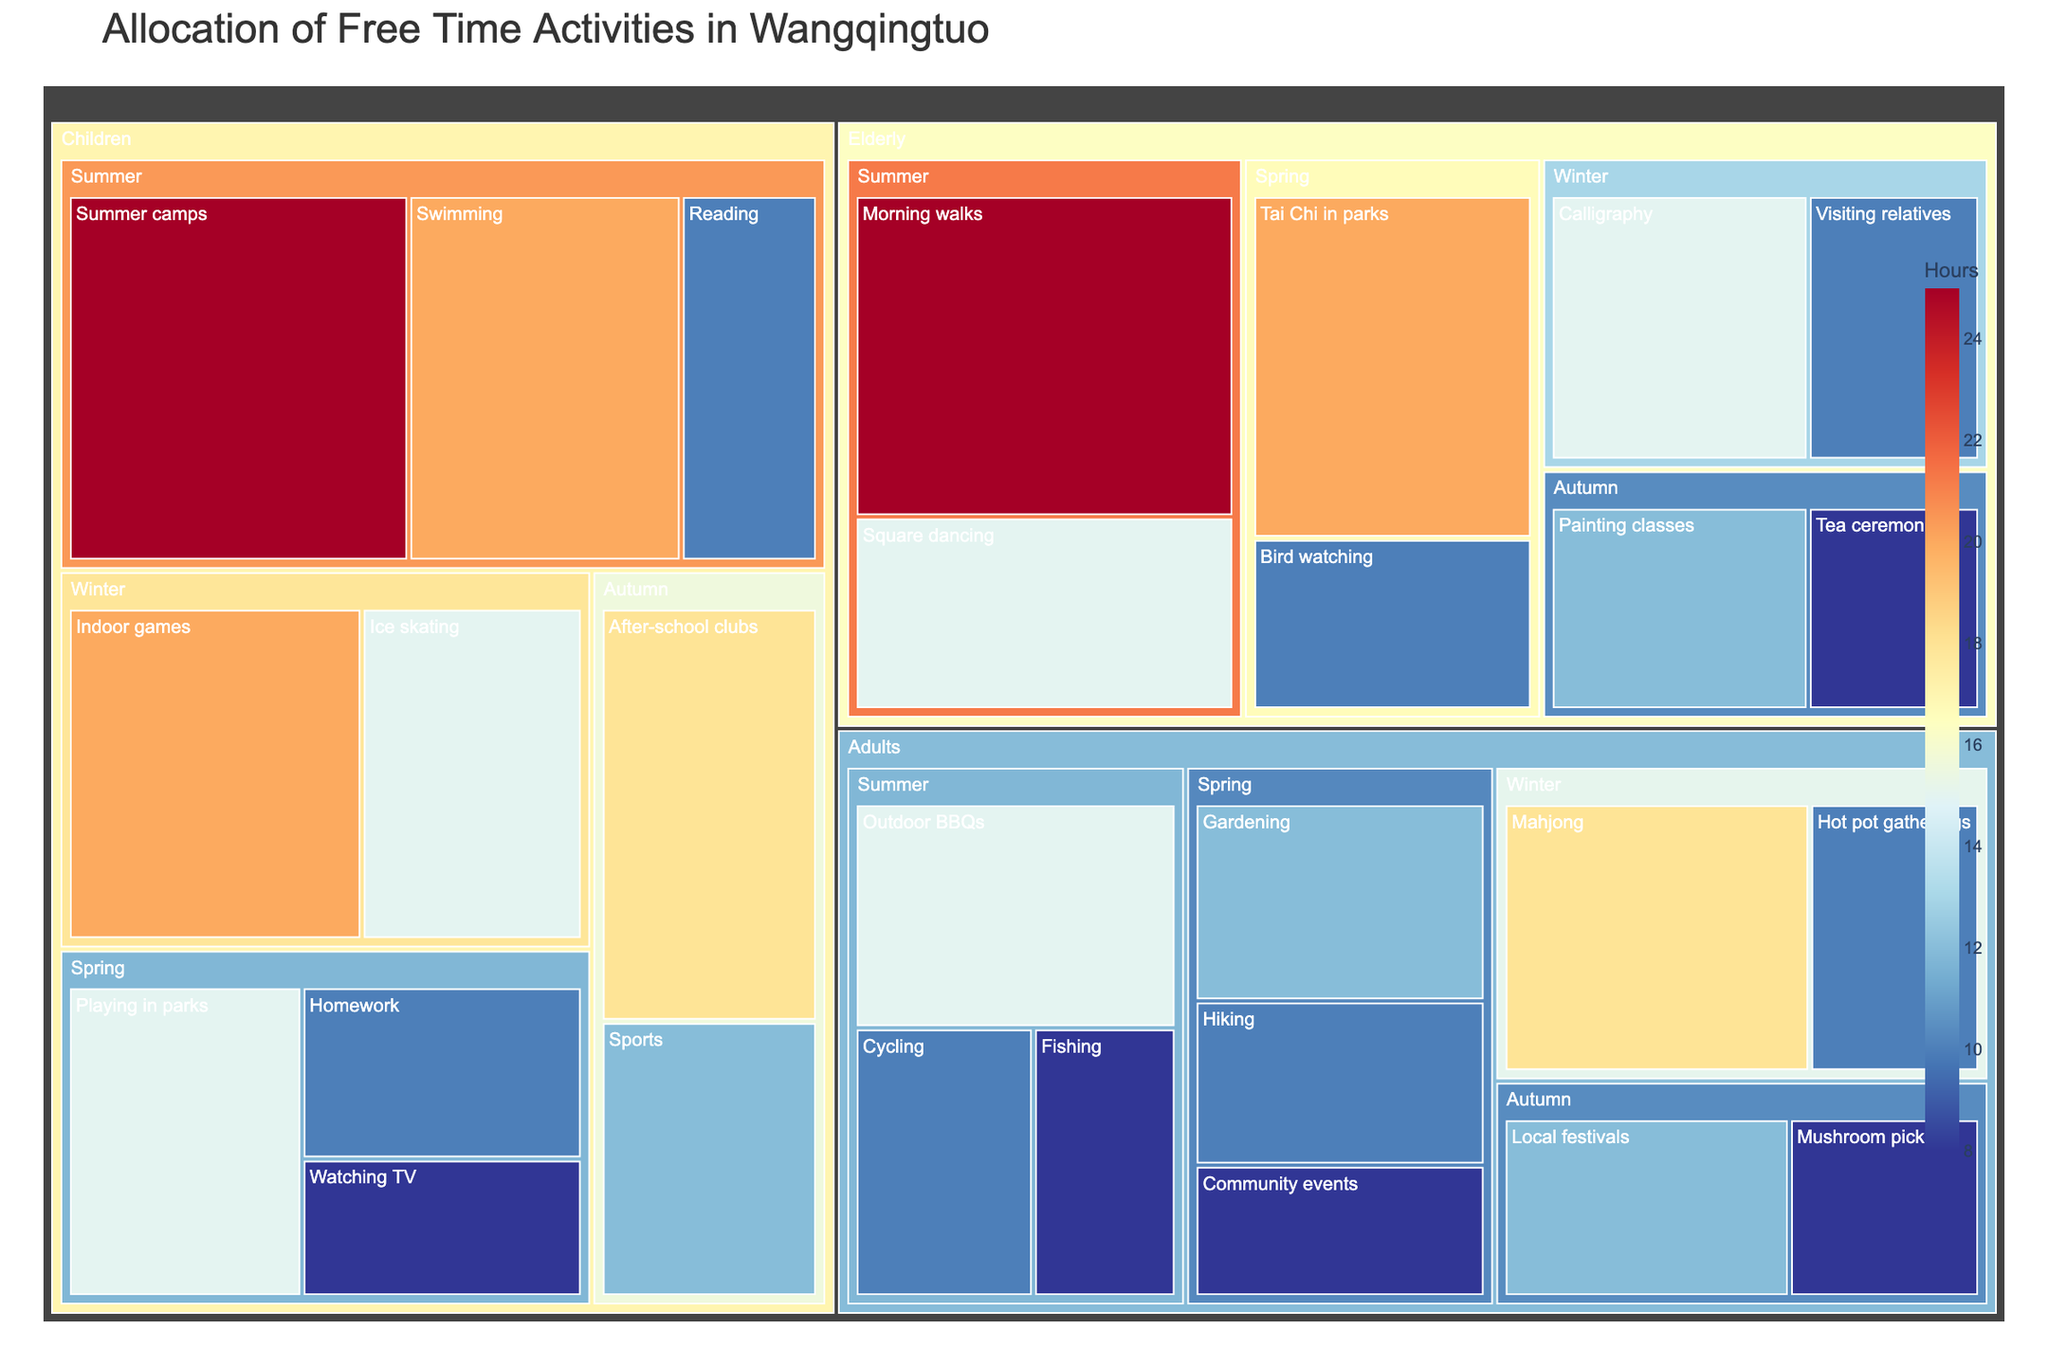what is the title of the figure? The title is displayed at the top of the treemap, indicating the main topic of the visualization. It reads: "Allocation of Free Time Activities in Wangqingtuo."
Answer: Allocation of Free Time Activities in Wangqingtuo what color represents the highest number of hours allocated to an activity? The treemap uses a continuous color scale. The highest number of hours is represented by the darkest blue color in the scale.
Answer: Dark blue which age group has the highest number of hours allocated to summer activities? By examining the summer section of the treemap, we can see which age group has the largest blocks. The Elderly age group has the largest blocks, indicating the highest number of hours allocated to activities.
Answer: Elderly How many hours are spent on Hot pot gatherings by Adults in Winter? Look at the Winter season within the Adults section of the treemap. The block labeled "Hot pot gatherings" shows it has been allotted 10 hours.
Answer: 10 hours Compare the total hours spent on sports activities by Children in Autumn with the total hours spent on outdoor BBQs by Adults in Summer. Which one is higher? Children in Autumn spend 12 hours on sports activities. Adults in Summer spend 15 hours on outdoor BBQs. Comparing these values, 15 hours is greater than 12 hours.
Answer: Outdoor BBQs by Adults in Summer What is the combined total of hours spent by Children on Playing in parks and Watching TV in Spring? Children spend 15 hours on Playing in parks and 8 hours on Watching TV in Spring. Summing these two values, we get 15 + 8 = 23 hours.
Answer: 23 hours Which season has the most diverse range of activities across all age groups? To find this, count the number of different activities listed for each season across all age groups. Summer has the highest number of unique activities (6 for Children, 3 for Adults, 2 for Elderly).
Answer: Summer What is the least popular activity for the Elderly in autumn? In the autumn section for the Elderly, there are two activities shown: Painting classes (12 hours) and Tea ceremonies (8 hours). The least popular is the one with fewer hours, Tea ceremonies.
Answer: Tea ceremonies 